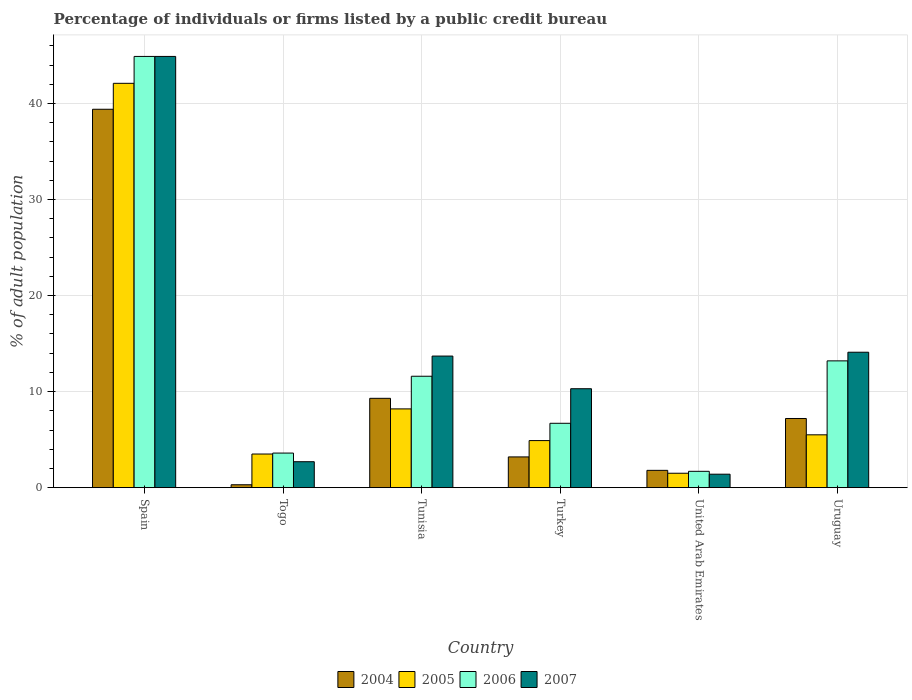How many groups of bars are there?
Your answer should be compact. 6. How many bars are there on the 5th tick from the left?
Provide a succinct answer. 4. How many bars are there on the 5th tick from the right?
Your answer should be compact. 4. What is the label of the 5th group of bars from the left?
Ensure brevity in your answer.  United Arab Emirates. Across all countries, what is the maximum percentage of population listed by a public credit bureau in 2007?
Give a very brief answer. 44.9. Across all countries, what is the minimum percentage of population listed by a public credit bureau in 2005?
Ensure brevity in your answer.  1.5. In which country was the percentage of population listed by a public credit bureau in 2005 maximum?
Your response must be concise. Spain. In which country was the percentage of population listed by a public credit bureau in 2006 minimum?
Provide a short and direct response. United Arab Emirates. What is the total percentage of population listed by a public credit bureau in 2006 in the graph?
Your answer should be compact. 81.7. What is the difference between the percentage of population listed by a public credit bureau in 2006 in Spain and that in Tunisia?
Your answer should be compact. 33.3. What is the difference between the percentage of population listed by a public credit bureau in 2004 in Togo and the percentage of population listed by a public credit bureau in 2007 in Spain?
Your answer should be compact. -44.6. What is the average percentage of population listed by a public credit bureau in 2007 per country?
Make the answer very short. 14.52. What is the difference between the percentage of population listed by a public credit bureau of/in 2006 and percentage of population listed by a public credit bureau of/in 2007 in United Arab Emirates?
Provide a succinct answer. 0.3. In how many countries, is the percentage of population listed by a public credit bureau in 2005 greater than 14 %?
Give a very brief answer. 1. What is the ratio of the percentage of population listed by a public credit bureau in 2005 in Spain to that in Turkey?
Offer a terse response. 8.59. Is the percentage of population listed by a public credit bureau in 2006 in Spain less than that in Togo?
Provide a succinct answer. No. Is the difference between the percentage of population listed by a public credit bureau in 2006 in Spain and Turkey greater than the difference between the percentage of population listed by a public credit bureau in 2007 in Spain and Turkey?
Your response must be concise. Yes. What is the difference between the highest and the second highest percentage of population listed by a public credit bureau in 2007?
Offer a very short reply. 31.2. What is the difference between the highest and the lowest percentage of population listed by a public credit bureau in 2007?
Provide a short and direct response. 43.5. In how many countries, is the percentage of population listed by a public credit bureau in 2006 greater than the average percentage of population listed by a public credit bureau in 2006 taken over all countries?
Give a very brief answer. 1. Is the sum of the percentage of population listed by a public credit bureau in 2004 in Togo and Tunisia greater than the maximum percentage of population listed by a public credit bureau in 2006 across all countries?
Offer a very short reply. No. Is it the case that in every country, the sum of the percentage of population listed by a public credit bureau in 2005 and percentage of population listed by a public credit bureau in 2007 is greater than the sum of percentage of population listed by a public credit bureau in 2004 and percentage of population listed by a public credit bureau in 2006?
Ensure brevity in your answer.  No. Is it the case that in every country, the sum of the percentage of population listed by a public credit bureau in 2005 and percentage of population listed by a public credit bureau in 2006 is greater than the percentage of population listed by a public credit bureau in 2004?
Ensure brevity in your answer.  Yes. How many bars are there?
Make the answer very short. 24. Does the graph contain any zero values?
Provide a short and direct response. No. Does the graph contain grids?
Keep it short and to the point. Yes. How are the legend labels stacked?
Keep it short and to the point. Horizontal. What is the title of the graph?
Keep it short and to the point. Percentage of individuals or firms listed by a public credit bureau. Does "1984" appear as one of the legend labels in the graph?
Keep it short and to the point. No. What is the label or title of the X-axis?
Offer a very short reply. Country. What is the label or title of the Y-axis?
Provide a short and direct response. % of adult population. What is the % of adult population in 2004 in Spain?
Provide a short and direct response. 39.4. What is the % of adult population of 2005 in Spain?
Ensure brevity in your answer.  42.1. What is the % of adult population of 2006 in Spain?
Offer a very short reply. 44.9. What is the % of adult population of 2007 in Spain?
Offer a terse response. 44.9. What is the % of adult population of 2004 in Togo?
Provide a short and direct response. 0.3. What is the % of adult population in 2004 in Tunisia?
Provide a short and direct response. 9.3. What is the % of adult population in 2007 in Tunisia?
Your answer should be compact. 13.7. What is the % of adult population in 2004 in Turkey?
Your answer should be compact. 3.2. What is the % of adult population in 2006 in United Arab Emirates?
Provide a short and direct response. 1.7. What is the % of adult population of 2007 in United Arab Emirates?
Provide a short and direct response. 1.4. Across all countries, what is the maximum % of adult population in 2004?
Make the answer very short. 39.4. Across all countries, what is the maximum % of adult population in 2005?
Give a very brief answer. 42.1. Across all countries, what is the maximum % of adult population of 2006?
Provide a short and direct response. 44.9. Across all countries, what is the maximum % of adult population in 2007?
Ensure brevity in your answer.  44.9. Across all countries, what is the minimum % of adult population of 2006?
Provide a short and direct response. 1.7. What is the total % of adult population of 2004 in the graph?
Your response must be concise. 61.2. What is the total % of adult population in 2005 in the graph?
Your answer should be very brief. 65.7. What is the total % of adult population of 2006 in the graph?
Make the answer very short. 81.7. What is the total % of adult population of 2007 in the graph?
Make the answer very short. 87.1. What is the difference between the % of adult population of 2004 in Spain and that in Togo?
Your answer should be compact. 39.1. What is the difference between the % of adult population in 2005 in Spain and that in Togo?
Your response must be concise. 38.6. What is the difference between the % of adult population of 2006 in Spain and that in Togo?
Provide a succinct answer. 41.3. What is the difference between the % of adult population of 2007 in Spain and that in Togo?
Keep it short and to the point. 42.2. What is the difference between the % of adult population in 2004 in Spain and that in Tunisia?
Provide a succinct answer. 30.1. What is the difference between the % of adult population in 2005 in Spain and that in Tunisia?
Keep it short and to the point. 33.9. What is the difference between the % of adult population of 2006 in Spain and that in Tunisia?
Offer a terse response. 33.3. What is the difference between the % of adult population of 2007 in Spain and that in Tunisia?
Make the answer very short. 31.2. What is the difference between the % of adult population of 2004 in Spain and that in Turkey?
Ensure brevity in your answer.  36.2. What is the difference between the % of adult population of 2005 in Spain and that in Turkey?
Provide a succinct answer. 37.2. What is the difference between the % of adult population of 2006 in Spain and that in Turkey?
Keep it short and to the point. 38.2. What is the difference between the % of adult population of 2007 in Spain and that in Turkey?
Provide a succinct answer. 34.6. What is the difference between the % of adult population in 2004 in Spain and that in United Arab Emirates?
Your answer should be very brief. 37.6. What is the difference between the % of adult population in 2005 in Spain and that in United Arab Emirates?
Provide a succinct answer. 40.6. What is the difference between the % of adult population of 2006 in Spain and that in United Arab Emirates?
Your answer should be very brief. 43.2. What is the difference between the % of adult population of 2007 in Spain and that in United Arab Emirates?
Your answer should be compact. 43.5. What is the difference between the % of adult population in 2004 in Spain and that in Uruguay?
Your answer should be compact. 32.2. What is the difference between the % of adult population in 2005 in Spain and that in Uruguay?
Offer a terse response. 36.6. What is the difference between the % of adult population of 2006 in Spain and that in Uruguay?
Give a very brief answer. 31.7. What is the difference between the % of adult population of 2007 in Spain and that in Uruguay?
Your answer should be very brief. 30.8. What is the difference between the % of adult population in 2004 in Togo and that in Tunisia?
Keep it short and to the point. -9. What is the difference between the % of adult population of 2005 in Togo and that in Tunisia?
Provide a short and direct response. -4.7. What is the difference between the % of adult population in 2004 in Togo and that in Turkey?
Your response must be concise. -2.9. What is the difference between the % of adult population in 2005 in Togo and that in Turkey?
Your response must be concise. -1.4. What is the difference between the % of adult population in 2006 in Togo and that in Turkey?
Provide a succinct answer. -3.1. What is the difference between the % of adult population in 2007 in Togo and that in Turkey?
Make the answer very short. -7.6. What is the difference between the % of adult population of 2004 in Togo and that in United Arab Emirates?
Offer a terse response. -1.5. What is the difference between the % of adult population in 2006 in Togo and that in United Arab Emirates?
Ensure brevity in your answer.  1.9. What is the difference between the % of adult population of 2005 in Togo and that in Uruguay?
Offer a very short reply. -2. What is the difference between the % of adult population in 2006 in Togo and that in Uruguay?
Your answer should be compact. -9.6. What is the difference between the % of adult population of 2006 in Tunisia and that in Turkey?
Your response must be concise. 4.9. What is the difference between the % of adult population of 2007 in Tunisia and that in Turkey?
Keep it short and to the point. 3.4. What is the difference between the % of adult population in 2005 in Tunisia and that in Uruguay?
Provide a short and direct response. 2.7. What is the difference between the % of adult population in 2006 in Tunisia and that in Uruguay?
Offer a terse response. -1.6. What is the difference between the % of adult population of 2007 in Tunisia and that in Uruguay?
Offer a very short reply. -0.4. What is the difference between the % of adult population in 2004 in Turkey and that in United Arab Emirates?
Provide a succinct answer. 1.4. What is the difference between the % of adult population of 2006 in Turkey and that in United Arab Emirates?
Provide a succinct answer. 5. What is the difference between the % of adult population of 2005 in Turkey and that in Uruguay?
Provide a short and direct response. -0.6. What is the difference between the % of adult population of 2004 in United Arab Emirates and that in Uruguay?
Your answer should be very brief. -5.4. What is the difference between the % of adult population of 2006 in United Arab Emirates and that in Uruguay?
Your answer should be compact. -11.5. What is the difference between the % of adult population in 2007 in United Arab Emirates and that in Uruguay?
Give a very brief answer. -12.7. What is the difference between the % of adult population in 2004 in Spain and the % of adult population in 2005 in Togo?
Keep it short and to the point. 35.9. What is the difference between the % of adult population in 2004 in Spain and the % of adult population in 2006 in Togo?
Your response must be concise. 35.8. What is the difference between the % of adult population in 2004 in Spain and the % of adult population in 2007 in Togo?
Provide a succinct answer. 36.7. What is the difference between the % of adult population in 2005 in Spain and the % of adult population in 2006 in Togo?
Your answer should be very brief. 38.5. What is the difference between the % of adult population in 2005 in Spain and the % of adult population in 2007 in Togo?
Your answer should be compact. 39.4. What is the difference between the % of adult population in 2006 in Spain and the % of adult population in 2007 in Togo?
Keep it short and to the point. 42.2. What is the difference between the % of adult population of 2004 in Spain and the % of adult population of 2005 in Tunisia?
Provide a succinct answer. 31.2. What is the difference between the % of adult population in 2004 in Spain and the % of adult population in 2006 in Tunisia?
Make the answer very short. 27.8. What is the difference between the % of adult population in 2004 in Spain and the % of adult population in 2007 in Tunisia?
Give a very brief answer. 25.7. What is the difference between the % of adult population of 2005 in Spain and the % of adult population of 2006 in Tunisia?
Your answer should be very brief. 30.5. What is the difference between the % of adult population in 2005 in Spain and the % of adult population in 2007 in Tunisia?
Your answer should be very brief. 28.4. What is the difference between the % of adult population in 2006 in Spain and the % of adult population in 2007 in Tunisia?
Offer a very short reply. 31.2. What is the difference between the % of adult population in 2004 in Spain and the % of adult population in 2005 in Turkey?
Your response must be concise. 34.5. What is the difference between the % of adult population of 2004 in Spain and the % of adult population of 2006 in Turkey?
Give a very brief answer. 32.7. What is the difference between the % of adult population of 2004 in Spain and the % of adult population of 2007 in Turkey?
Your answer should be compact. 29.1. What is the difference between the % of adult population in 2005 in Spain and the % of adult population in 2006 in Turkey?
Give a very brief answer. 35.4. What is the difference between the % of adult population in 2005 in Spain and the % of adult population in 2007 in Turkey?
Your answer should be very brief. 31.8. What is the difference between the % of adult population of 2006 in Spain and the % of adult population of 2007 in Turkey?
Your answer should be compact. 34.6. What is the difference between the % of adult population in 2004 in Spain and the % of adult population in 2005 in United Arab Emirates?
Offer a terse response. 37.9. What is the difference between the % of adult population in 2004 in Spain and the % of adult population in 2006 in United Arab Emirates?
Your response must be concise. 37.7. What is the difference between the % of adult population of 2005 in Spain and the % of adult population of 2006 in United Arab Emirates?
Provide a short and direct response. 40.4. What is the difference between the % of adult population of 2005 in Spain and the % of adult population of 2007 in United Arab Emirates?
Offer a very short reply. 40.7. What is the difference between the % of adult population in 2006 in Spain and the % of adult population in 2007 in United Arab Emirates?
Keep it short and to the point. 43.5. What is the difference between the % of adult population in 2004 in Spain and the % of adult population in 2005 in Uruguay?
Offer a terse response. 33.9. What is the difference between the % of adult population in 2004 in Spain and the % of adult population in 2006 in Uruguay?
Your response must be concise. 26.2. What is the difference between the % of adult population in 2004 in Spain and the % of adult population in 2007 in Uruguay?
Make the answer very short. 25.3. What is the difference between the % of adult population of 2005 in Spain and the % of adult population of 2006 in Uruguay?
Give a very brief answer. 28.9. What is the difference between the % of adult population in 2006 in Spain and the % of adult population in 2007 in Uruguay?
Provide a short and direct response. 30.8. What is the difference between the % of adult population of 2004 in Togo and the % of adult population of 2005 in Tunisia?
Make the answer very short. -7.9. What is the difference between the % of adult population in 2004 in Togo and the % of adult population in 2007 in Tunisia?
Offer a terse response. -13.4. What is the difference between the % of adult population in 2005 in Togo and the % of adult population in 2007 in Tunisia?
Your answer should be compact. -10.2. What is the difference between the % of adult population in 2006 in Togo and the % of adult population in 2007 in Tunisia?
Keep it short and to the point. -10.1. What is the difference between the % of adult population in 2004 in Togo and the % of adult population in 2005 in Turkey?
Offer a terse response. -4.6. What is the difference between the % of adult population of 2005 in Togo and the % of adult population of 2006 in Turkey?
Your response must be concise. -3.2. What is the difference between the % of adult population of 2006 in Togo and the % of adult population of 2007 in Turkey?
Make the answer very short. -6.7. What is the difference between the % of adult population of 2004 in Togo and the % of adult population of 2007 in United Arab Emirates?
Offer a very short reply. -1.1. What is the difference between the % of adult population in 2005 in Togo and the % of adult population in 2006 in United Arab Emirates?
Offer a terse response. 1.8. What is the difference between the % of adult population of 2005 in Togo and the % of adult population of 2007 in United Arab Emirates?
Keep it short and to the point. 2.1. What is the difference between the % of adult population in 2004 in Togo and the % of adult population in 2005 in Uruguay?
Your response must be concise. -5.2. What is the difference between the % of adult population in 2004 in Tunisia and the % of adult population in 2006 in Turkey?
Your response must be concise. 2.6. What is the difference between the % of adult population in 2005 in Tunisia and the % of adult population in 2006 in Turkey?
Make the answer very short. 1.5. What is the difference between the % of adult population of 2004 in Tunisia and the % of adult population of 2005 in United Arab Emirates?
Give a very brief answer. 7.8. What is the difference between the % of adult population of 2004 in Tunisia and the % of adult population of 2006 in United Arab Emirates?
Ensure brevity in your answer.  7.6. What is the difference between the % of adult population of 2006 in Tunisia and the % of adult population of 2007 in United Arab Emirates?
Provide a succinct answer. 10.2. What is the difference between the % of adult population of 2004 in Turkey and the % of adult population of 2006 in United Arab Emirates?
Offer a very short reply. 1.5. What is the difference between the % of adult population of 2005 in Turkey and the % of adult population of 2006 in United Arab Emirates?
Provide a short and direct response. 3.2. What is the difference between the % of adult population in 2006 in Turkey and the % of adult population in 2007 in United Arab Emirates?
Ensure brevity in your answer.  5.3. What is the difference between the % of adult population in 2004 in Turkey and the % of adult population in 2006 in Uruguay?
Provide a short and direct response. -10. What is the difference between the % of adult population in 2004 in Turkey and the % of adult population in 2007 in Uruguay?
Provide a short and direct response. -10.9. What is the difference between the % of adult population of 2005 in Turkey and the % of adult population of 2006 in Uruguay?
Make the answer very short. -8.3. What is the difference between the % of adult population in 2005 in Turkey and the % of adult population in 2007 in Uruguay?
Offer a terse response. -9.2. What is the difference between the % of adult population in 2006 in Turkey and the % of adult population in 2007 in Uruguay?
Provide a succinct answer. -7.4. What is the difference between the % of adult population in 2004 in United Arab Emirates and the % of adult population in 2006 in Uruguay?
Your response must be concise. -11.4. What is the average % of adult population in 2005 per country?
Ensure brevity in your answer.  10.95. What is the average % of adult population of 2006 per country?
Make the answer very short. 13.62. What is the average % of adult population of 2007 per country?
Provide a succinct answer. 14.52. What is the difference between the % of adult population in 2004 and % of adult population in 2005 in Spain?
Offer a terse response. -2.7. What is the difference between the % of adult population of 2005 and % of adult population of 2007 in Spain?
Offer a very short reply. -2.8. What is the difference between the % of adult population in 2004 and % of adult population in 2006 in Togo?
Keep it short and to the point. -3.3. What is the difference between the % of adult population in 2004 and % of adult population in 2007 in Togo?
Your answer should be compact. -2.4. What is the difference between the % of adult population of 2006 and % of adult population of 2007 in Togo?
Give a very brief answer. 0.9. What is the difference between the % of adult population of 2004 and % of adult population of 2007 in Tunisia?
Provide a short and direct response. -4.4. What is the difference between the % of adult population of 2006 and % of adult population of 2007 in Tunisia?
Your answer should be very brief. -2.1. What is the difference between the % of adult population of 2004 and % of adult population of 2007 in Turkey?
Make the answer very short. -7.1. What is the difference between the % of adult population in 2005 and % of adult population in 2007 in Turkey?
Provide a succinct answer. -5.4. What is the difference between the % of adult population of 2004 and % of adult population of 2006 in United Arab Emirates?
Your answer should be very brief. 0.1. What is the difference between the % of adult population of 2004 and % of adult population of 2007 in United Arab Emirates?
Provide a succinct answer. 0.4. What is the difference between the % of adult population of 2005 and % of adult population of 2007 in United Arab Emirates?
Ensure brevity in your answer.  0.1. What is the difference between the % of adult population in 2006 and % of adult population in 2007 in United Arab Emirates?
Offer a very short reply. 0.3. What is the difference between the % of adult population in 2004 and % of adult population in 2005 in Uruguay?
Ensure brevity in your answer.  1.7. What is the difference between the % of adult population of 2005 and % of adult population of 2006 in Uruguay?
Make the answer very short. -7.7. What is the difference between the % of adult population in 2006 and % of adult population in 2007 in Uruguay?
Your answer should be compact. -0.9. What is the ratio of the % of adult population in 2004 in Spain to that in Togo?
Your answer should be compact. 131.33. What is the ratio of the % of adult population in 2005 in Spain to that in Togo?
Give a very brief answer. 12.03. What is the ratio of the % of adult population of 2006 in Spain to that in Togo?
Provide a short and direct response. 12.47. What is the ratio of the % of adult population of 2007 in Spain to that in Togo?
Offer a terse response. 16.63. What is the ratio of the % of adult population in 2004 in Spain to that in Tunisia?
Give a very brief answer. 4.24. What is the ratio of the % of adult population of 2005 in Spain to that in Tunisia?
Ensure brevity in your answer.  5.13. What is the ratio of the % of adult population in 2006 in Spain to that in Tunisia?
Make the answer very short. 3.87. What is the ratio of the % of adult population in 2007 in Spain to that in Tunisia?
Offer a terse response. 3.28. What is the ratio of the % of adult population of 2004 in Spain to that in Turkey?
Ensure brevity in your answer.  12.31. What is the ratio of the % of adult population of 2005 in Spain to that in Turkey?
Your answer should be compact. 8.59. What is the ratio of the % of adult population in 2006 in Spain to that in Turkey?
Give a very brief answer. 6.7. What is the ratio of the % of adult population of 2007 in Spain to that in Turkey?
Your answer should be compact. 4.36. What is the ratio of the % of adult population in 2004 in Spain to that in United Arab Emirates?
Make the answer very short. 21.89. What is the ratio of the % of adult population in 2005 in Spain to that in United Arab Emirates?
Provide a succinct answer. 28.07. What is the ratio of the % of adult population of 2006 in Spain to that in United Arab Emirates?
Provide a short and direct response. 26.41. What is the ratio of the % of adult population of 2007 in Spain to that in United Arab Emirates?
Ensure brevity in your answer.  32.07. What is the ratio of the % of adult population in 2004 in Spain to that in Uruguay?
Ensure brevity in your answer.  5.47. What is the ratio of the % of adult population in 2005 in Spain to that in Uruguay?
Provide a succinct answer. 7.65. What is the ratio of the % of adult population in 2006 in Spain to that in Uruguay?
Make the answer very short. 3.4. What is the ratio of the % of adult population in 2007 in Spain to that in Uruguay?
Offer a very short reply. 3.18. What is the ratio of the % of adult population in 2004 in Togo to that in Tunisia?
Give a very brief answer. 0.03. What is the ratio of the % of adult population in 2005 in Togo to that in Tunisia?
Make the answer very short. 0.43. What is the ratio of the % of adult population in 2006 in Togo to that in Tunisia?
Offer a terse response. 0.31. What is the ratio of the % of adult population in 2007 in Togo to that in Tunisia?
Your response must be concise. 0.2. What is the ratio of the % of adult population of 2004 in Togo to that in Turkey?
Make the answer very short. 0.09. What is the ratio of the % of adult population of 2006 in Togo to that in Turkey?
Offer a terse response. 0.54. What is the ratio of the % of adult population of 2007 in Togo to that in Turkey?
Keep it short and to the point. 0.26. What is the ratio of the % of adult population in 2005 in Togo to that in United Arab Emirates?
Your answer should be very brief. 2.33. What is the ratio of the % of adult population of 2006 in Togo to that in United Arab Emirates?
Keep it short and to the point. 2.12. What is the ratio of the % of adult population in 2007 in Togo to that in United Arab Emirates?
Offer a very short reply. 1.93. What is the ratio of the % of adult population in 2004 in Togo to that in Uruguay?
Provide a short and direct response. 0.04. What is the ratio of the % of adult population in 2005 in Togo to that in Uruguay?
Offer a terse response. 0.64. What is the ratio of the % of adult population in 2006 in Togo to that in Uruguay?
Offer a very short reply. 0.27. What is the ratio of the % of adult population in 2007 in Togo to that in Uruguay?
Your response must be concise. 0.19. What is the ratio of the % of adult population in 2004 in Tunisia to that in Turkey?
Make the answer very short. 2.91. What is the ratio of the % of adult population in 2005 in Tunisia to that in Turkey?
Your answer should be compact. 1.67. What is the ratio of the % of adult population in 2006 in Tunisia to that in Turkey?
Provide a short and direct response. 1.73. What is the ratio of the % of adult population of 2007 in Tunisia to that in Turkey?
Offer a terse response. 1.33. What is the ratio of the % of adult population of 2004 in Tunisia to that in United Arab Emirates?
Give a very brief answer. 5.17. What is the ratio of the % of adult population of 2005 in Tunisia to that in United Arab Emirates?
Provide a short and direct response. 5.47. What is the ratio of the % of adult population in 2006 in Tunisia to that in United Arab Emirates?
Provide a short and direct response. 6.82. What is the ratio of the % of adult population of 2007 in Tunisia to that in United Arab Emirates?
Your answer should be compact. 9.79. What is the ratio of the % of adult population of 2004 in Tunisia to that in Uruguay?
Make the answer very short. 1.29. What is the ratio of the % of adult population in 2005 in Tunisia to that in Uruguay?
Offer a terse response. 1.49. What is the ratio of the % of adult population in 2006 in Tunisia to that in Uruguay?
Your answer should be compact. 0.88. What is the ratio of the % of adult population of 2007 in Tunisia to that in Uruguay?
Your answer should be compact. 0.97. What is the ratio of the % of adult population in 2004 in Turkey to that in United Arab Emirates?
Your answer should be compact. 1.78. What is the ratio of the % of adult population in 2005 in Turkey to that in United Arab Emirates?
Provide a short and direct response. 3.27. What is the ratio of the % of adult population of 2006 in Turkey to that in United Arab Emirates?
Keep it short and to the point. 3.94. What is the ratio of the % of adult population in 2007 in Turkey to that in United Arab Emirates?
Make the answer very short. 7.36. What is the ratio of the % of adult population in 2004 in Turkey to that in Uruguay?
Offer a very short reply. 0.44. What is the ratio of the % of adult population of 2005 in Turkey to that in Uruguay?
Your answer should be compact. 0.89. What is the ratio of the % of adult population in 2006 in Turkey to that in Uruguay?
Ensure brevity in your answer.  0.51. What is the ratio of the % of adult population in 2007 in Turkey to that in Uruguay?
Your answer should be very brief. 0.73. What is the ratio of the % of adult population of 2005 in United Arab Emirates to that in Uruguay?
Your response must be concise. 0.27. What is the ratio of the % of adult population in 2006 in United Arab Emirates to that in Uruguay?
Ensure brevity in your answer.  0.13. What is the ratio of the % of adult population of 2007 in United Arab Emirates to that in Uruguay?
Give a very brief answer. 0.1. What is the difference between the highest and the second highest % of adult population in 2004?
Keep it short and to the point. 30.1. What is the difference between the highest and the second highest % of adult population of 2005?
Give a very brief answer. 33.9. What is the difference between the highest and the second highest % of adult population of 2006?
Keep it short and to the point. 31.7. What is the difference between the highest and the second highest % of adult population in 2007?
Your answer should be very brief. 30.8. What is the difference between the highest and the lowest % of adult population of 2004?
Provide a short and direct response. 39.1. What is the difference between the highest and the lowest % of adult population of 2005?
Ensure brevity in your answer.  40.6. What is the difference between the highest and the lowest % of adult population of 2006?
Your answer should be compact. 43.2. What is the difference between the highest and the lowest % of adult population of 2007?
Provide a succinct answer. 43.5. 